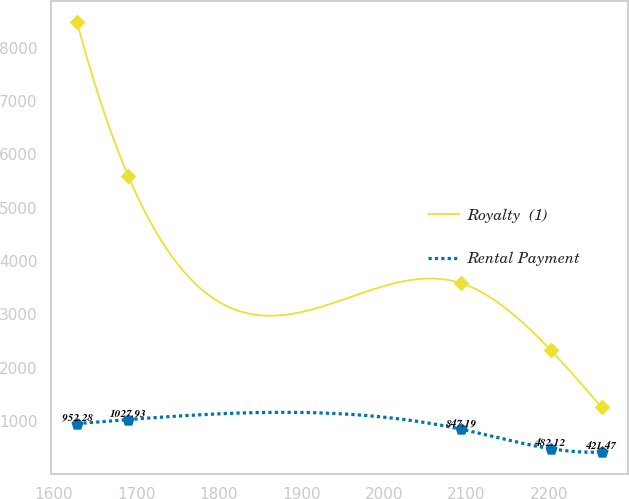Convert chart to OTSL. <chart><loc_0><loc_0><loc_500><loc_500><line_chart><ecel><fcel>Royalty  (1)<fcel>Rental Payment<nl><fcel>1628.03<fcel>8475.26<fcel>952.28<nl><fcel>1689.99<fcel>5598.08<fcel>1027.93<nl><fcel>2093.71<fcel>3584.79<fcel>847.19<nl><fcel>2202.26<fcel>2331.82<fcel>482.12<nl><fcel>2264.22<fcel>1255.11<fcel>421.47<nl></chart> 